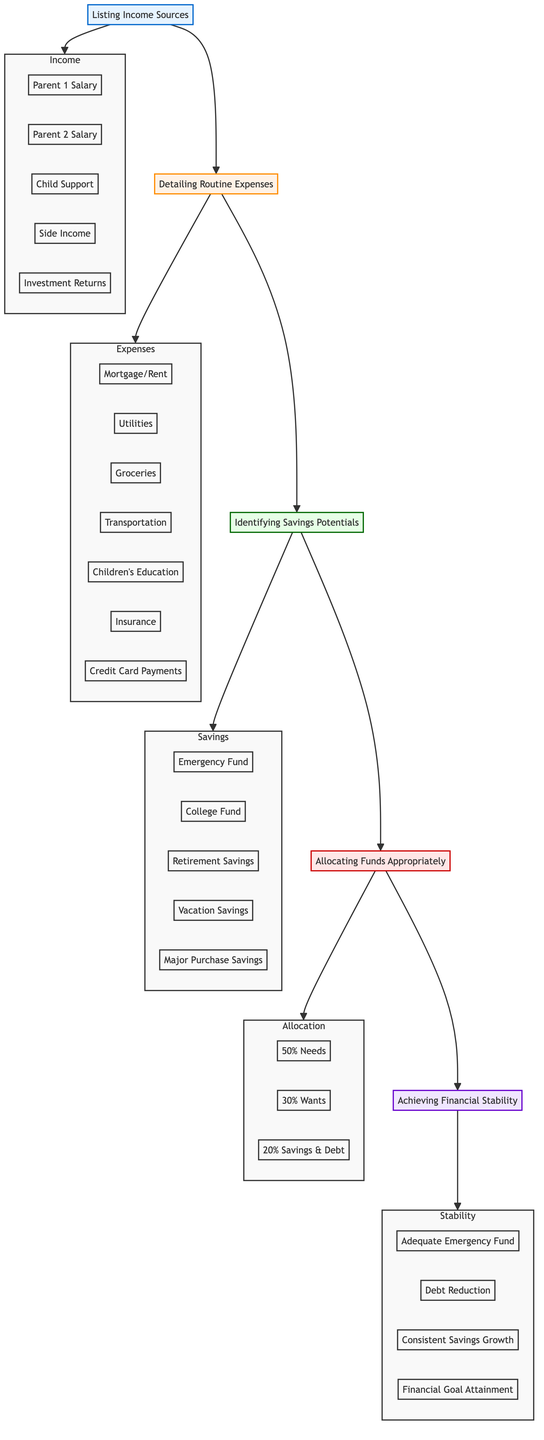what is the base element of the flow chart? The base element is the starting point of the flow chart, which is the first element from the bottom of the diagram. According to the diagram, this element is "Listing Income Sources."
Answer: Listing Income Sources how many detail items are listed under "Detailing Routine Expenses"? To find the number of detail items, we need to count the items listed under the "Detailing Routine Expenses" element. There are seven itemized details: "Mortgage/Rent," "Utilities," "Groceries," "Transportation," "Children's Education," "Insurance," and "Credit Card Payments."
Answer: 7 what percentage of allocated funds is designated for "Wants"? The allocation for "Wants" is specified directly in the section labeled "Allocating Funds Appropriately." It is indicated as 30%.
Answer: 30% which stage comes directly after "Identifying Savings Potentials"? We observe the flow from "Identifying Savings Potentials" to the next node. The flow is upward, and the direct subsequent stage is "Allocating Funds Appropriately."
Answer: Allocating Funds Appropriately if successful in achieving financial stability, what is one of the outcomes listed? The outcomes of achieving financial stability are indicated in the top element of the diagram labeled "Achieving Financial Stability." One of the outcomes listed is "Adequate Emergency Fund."
Answer: Adequate Emergency Fund what is the total number of elements in the flow chart? The total number of elements includes all the distinct levels in the chart from the bottom to the top. There are five main elements: "Listing Income Sources," "Detailing Routine Expenses," "Identifying Savings Potentials," "Allocating Funds Appropriately," and "Achieving Financial Stability." Therefore, the total is five.
Answer: 5 in which section would you find "Vacation Savings"? We can locate "Vacation Savings" by examining the levels of the flow chart. It is categorized under "Identifying Savings Potentials," as detailed in that part of the diagram.
Answer: Identifying Savings Potentials what is the first step in establishing a household budget? The first step in the whole budgeting process is depicted at the base of the flow chart. It corresponds to the element titled "Listing Income Sources."
Answer: Listing Income Sources 